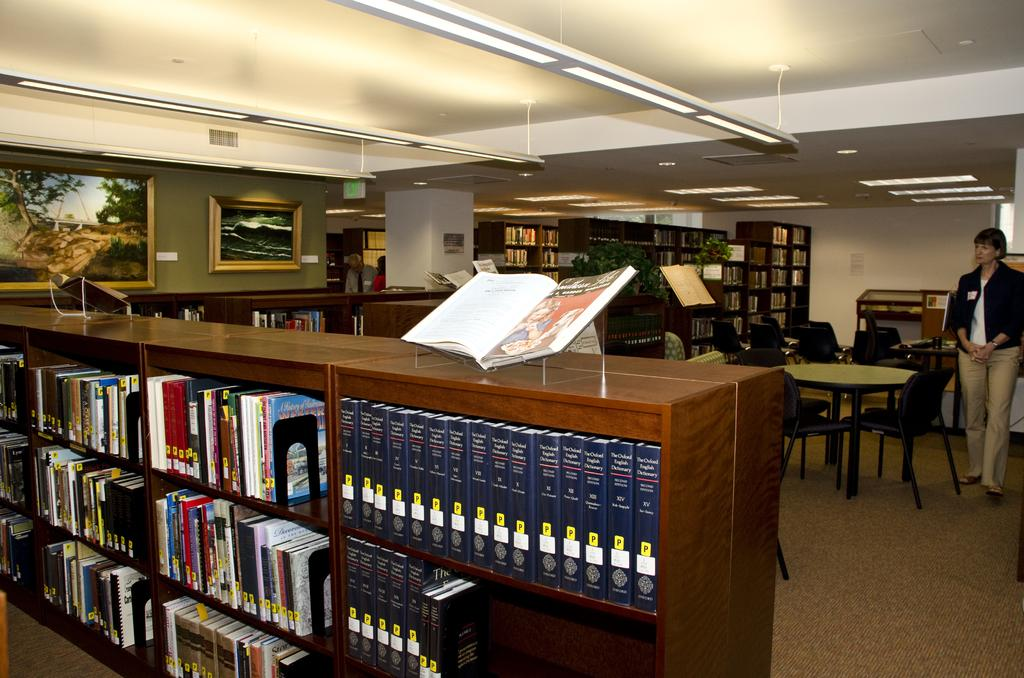What type of furniture is present in the image? There are bookshelves, chairs, and a table in the image. What is the woman standing in the image doing? The facts provided do not specify what the woman is doing. Can you describe the setting in which the furniture is located? The facts provided do not specify the setting of the furniture. What type of adjustment can be seen on the woman's nose in the image? There is no woman's nose present in the image, and therefore no such adjustment can be observed. What type of coil is wrapped around the bookshelves in the image? There is no coil present in the image, and therefore no such coil can be observed. 